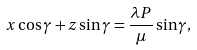Convert formula to latex. <formula><loc_0><loc_0><loc_500><loc_500>x \cos \gamma + z \sin \gamma = \frac { \lambda P } { \mu } \sin \gamma ,</formula> 